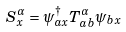Convert formula to latex. <formula><loc_0><loc_0><loc_500><loc_500>S ^ { \alpha } _ { x } = \psi _ { a x } ^ { \dagger } T _ { a b } ^ { \alpha } \psi _ { b x }</formula> 